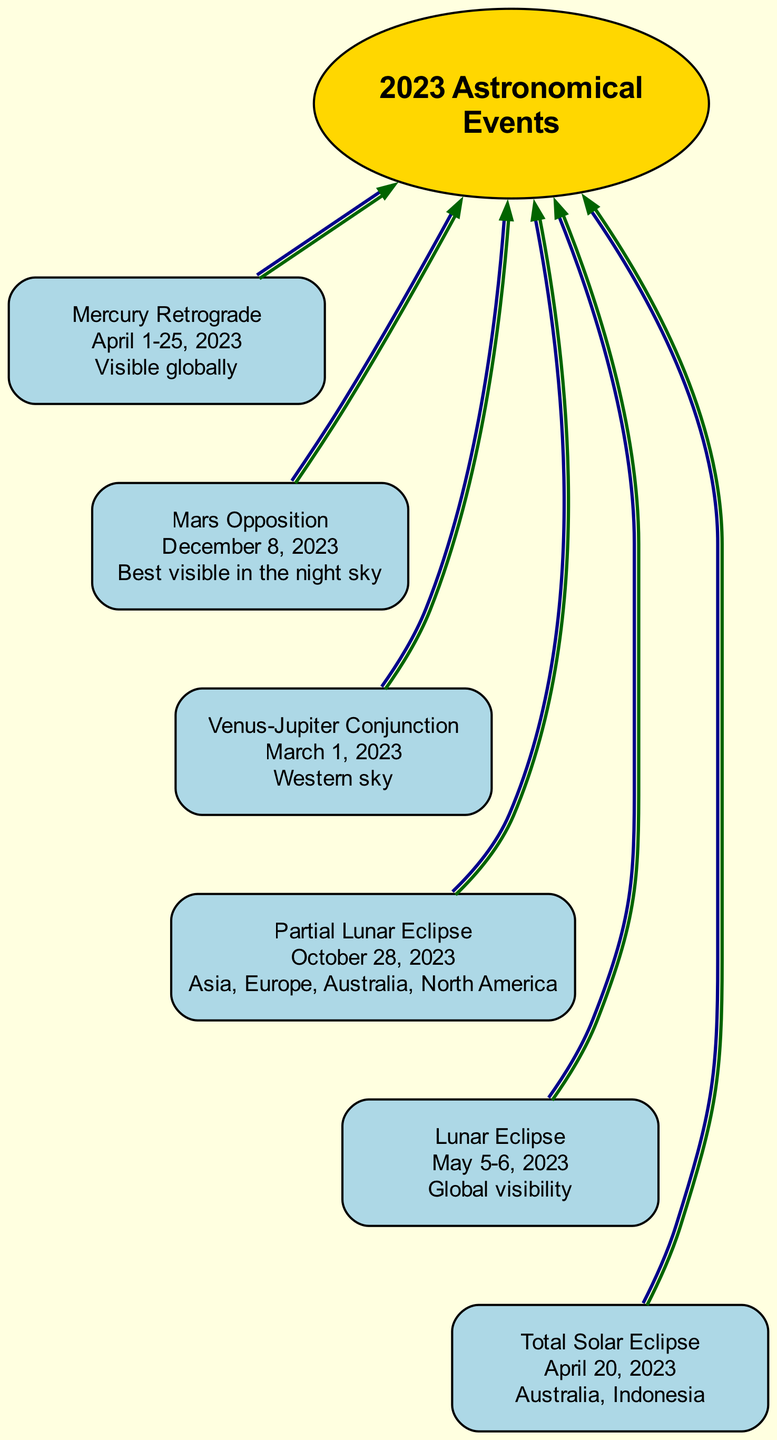What is the date of the Total Solar Eclipse? The diagram shows that the Total Solar Eclipse occurred on April 20, 2023, as indicated in the specific node for this event.
Answer: April 20, 2023 Which event occurs after the Venus-Jupiter Conjunction? The diagram connects the Venus-Jupiter Conjunction node to the Mars Opposition node, indicating that Mars Opposition is the next event in the sequence.
Answer: Mars Opposition How many major astronomical events are depicted in the diagram? By counting the nodes listed in the diagram, there are six major astronomical events detailed in the visual representation.
Answer: 6 What location is best for observing the Partial Lunar Eclipse? The Partial Lunar Eclipse node specifies that it is visible in Asia, Europe, Australia, and North America, thus those regions are the best for observation.
Answer: Asia, Europe, Australia, North America Which event is referred to as a penumbral lunar eclipse? The diagram shows that the event specifically described as a penumbral lunar eclipse is the Lunar Eclipse occurring on May 5-6, 2023.
Answer: Lunar Eclipse What event has global visibility? The diagram states that the Mercury Retrograde event, occurring from April 1-25, 2023, is noted for its global visibility.
Answer: Mercury Retrograde What is the overarching theme or central concept of this diagram? The central node labeled as "2023 Astronomical Events" indicates that the theme of the diagram encompasses the major astronomical events occurring in 2023.
Answer: 2023 Astronomical Events Which astronomical event is indicated to appear bright and close to Earth? The diagram identifies the Mars Opposition as the event that appears bright and close to Earth, scheduled for December 8, 2023.
Answer: Mars Opposition What type of event is the conjunction of Venus and Jupiter? According to the diagram, the close approach of Venus and Jupiter on March 1, 2023, is classified as a conjunction.
Answer: Conjunction 